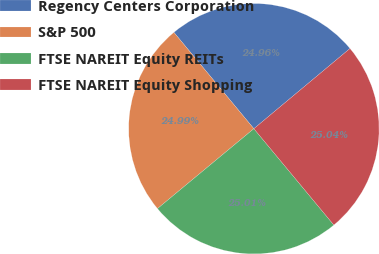Convert chart to OTSL. <chart><loc_0><loc_0><loc_500><loc_500><pie_chart><fcel>Regency Centers Corporation<fcel>S&P 500<fcel>FTSE NAREIT Equity REITs<fcel>FTSE NAREIT Equity Shopping<nl><fcel>24.96%<fcel>24.99%<fcel>25.01%<fcel>25.04%<nl></chart> 